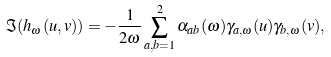Convert formula to latex. <formula><loc_0><loc_0><loc_500><loc_500>\Im ( h _ { \omega } ( u , v ) ) = - \frac { 1 } { 2 \omega } \sum _ { a , b = 1 } ^ { 2 } \alpha _ { a b } ( \omega ) \gamma _ { a , \omega } ( u ) \gamma _ { b , \omega } ( v ) ,</formula> 